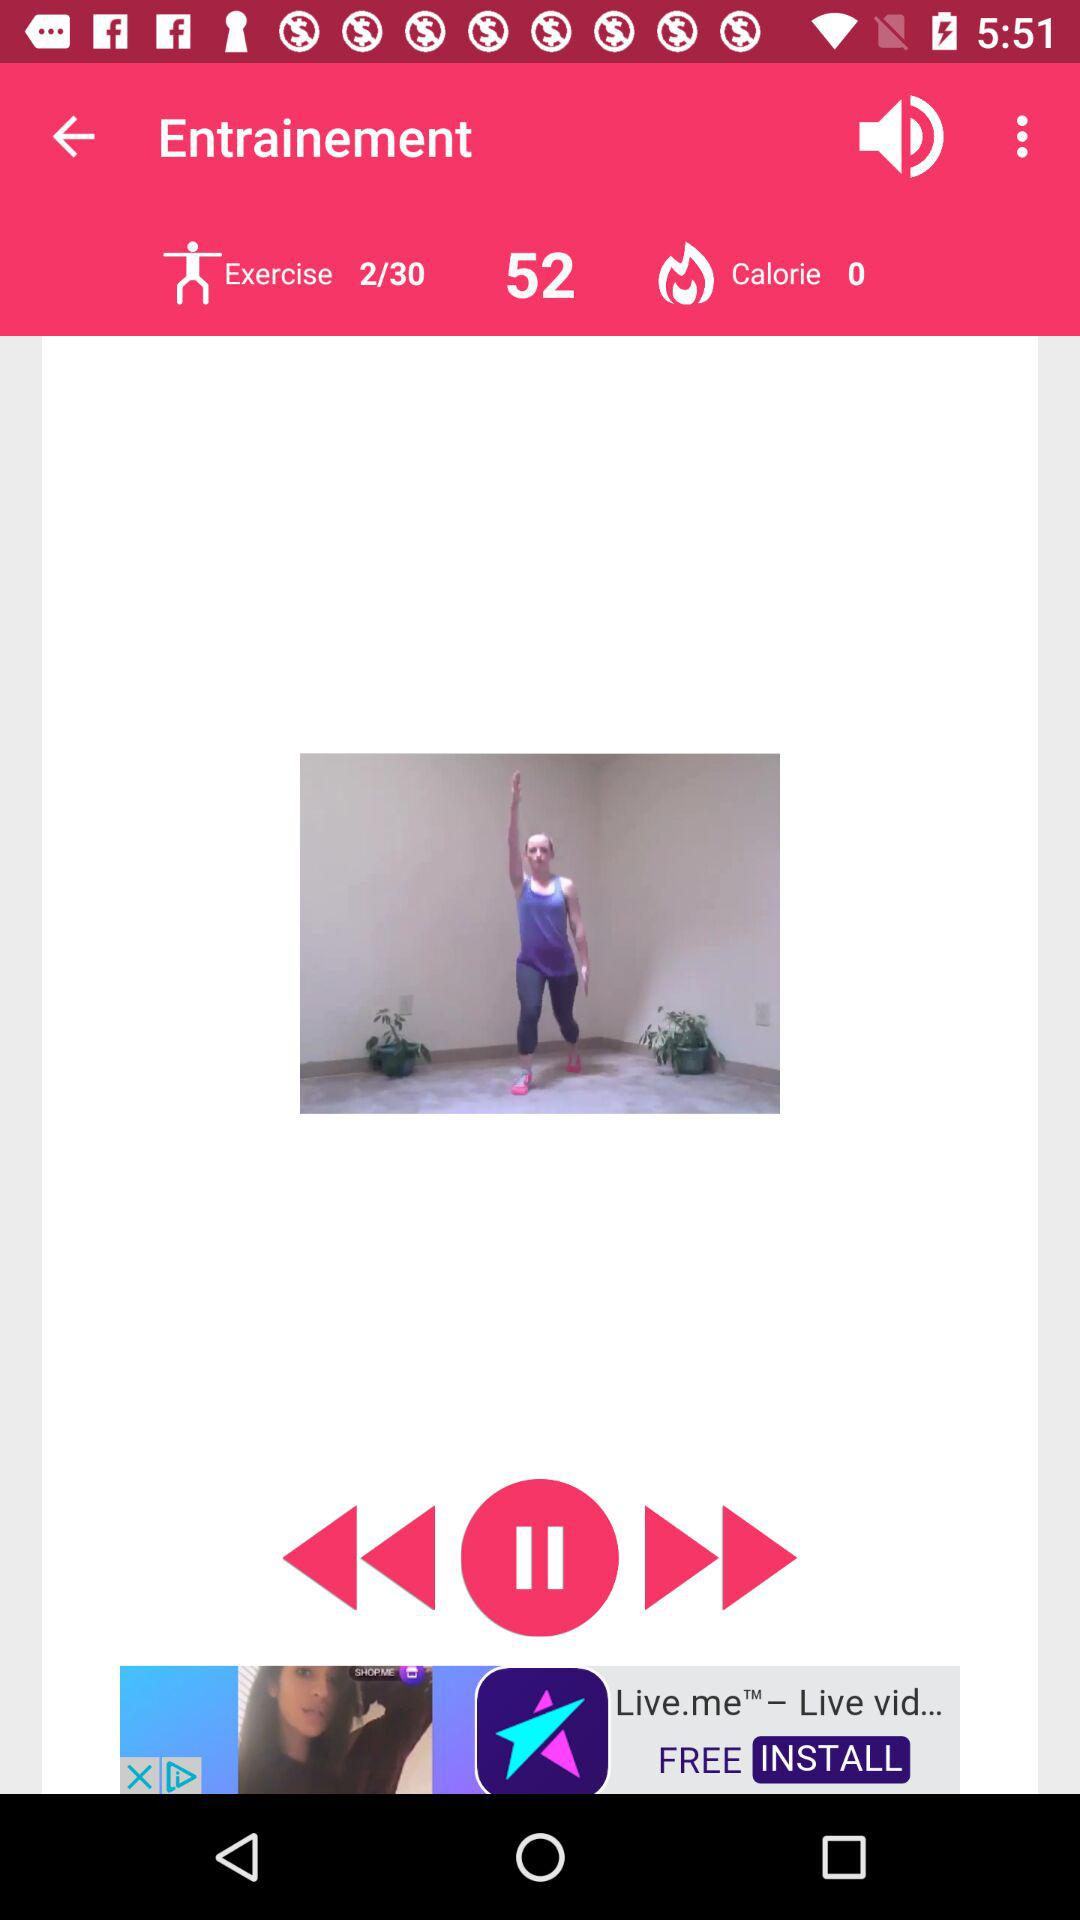What is the count of burned calories? The count of burned calories is 0. 